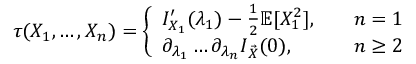<formula> <loc_0><loc_0><loc_500><loc_500>\begin{array} { r l } & { \tau ( X _ { 1 } , \dots , X _ { n } ) = \left \{ \begin{array} { l l } { I _ { X _ { 1 } } ^ { \prime } ( \lambda _ { 1 } ) - \frac { 1 } { 2 } \mathbb { E } [ X _ { 1 } ^ { 2 } ] , \quad } & { n = 1 } \\ { \partial _ { \lambda _ { 1 } } \dots \partial _ { \lambda _ { n } } I _ { \vec { X } } ( 0 ) , \quad } & { n \geq 2 } \end{array} } \end{array}</formula> 